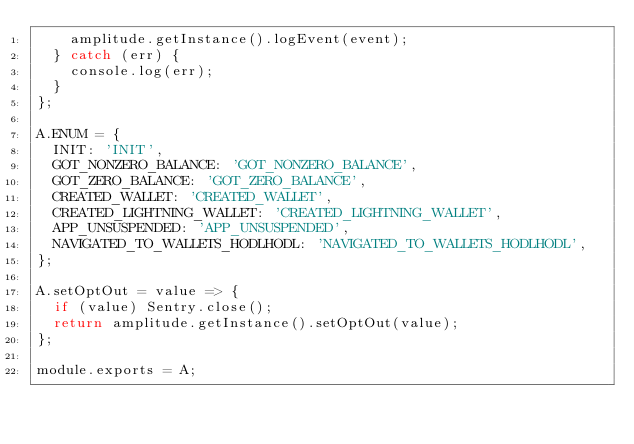<code> <loc_0><loc_0><loc_500><loc_500><_JavaScript_>    amplitude.getInstance().logEvent(event);
  } catch (err) {
    console.log(err);
  }
};

A.ENUM = {
  INIT: 'INIT',
  GOT_NONZERO_BALANCE: 'GOT_NONZERO_BALANCE',
  GOT_ZERO_BALANCE: 'GOT_ZERO_BALANCE',
  CREATED_WALLET: 'CREATED_WALLET',
  CREATED_LIGHTNING_WALLET: 'CREATED_LIGHTNING_WALLET',
  APP_UNSUSPENDED: 'APP_UNSUSPENDED',
  NAVIGATED_TO_WALLETS_HODLHODL: 'NAVIGATED_TO_WALLETS_HODLHODL',
};

A.setOptOut = value => {
  if (value) Sentry.close();
  return amplitude.getInstance().setOptOut(value);
};

module.exports = A;
</code> 